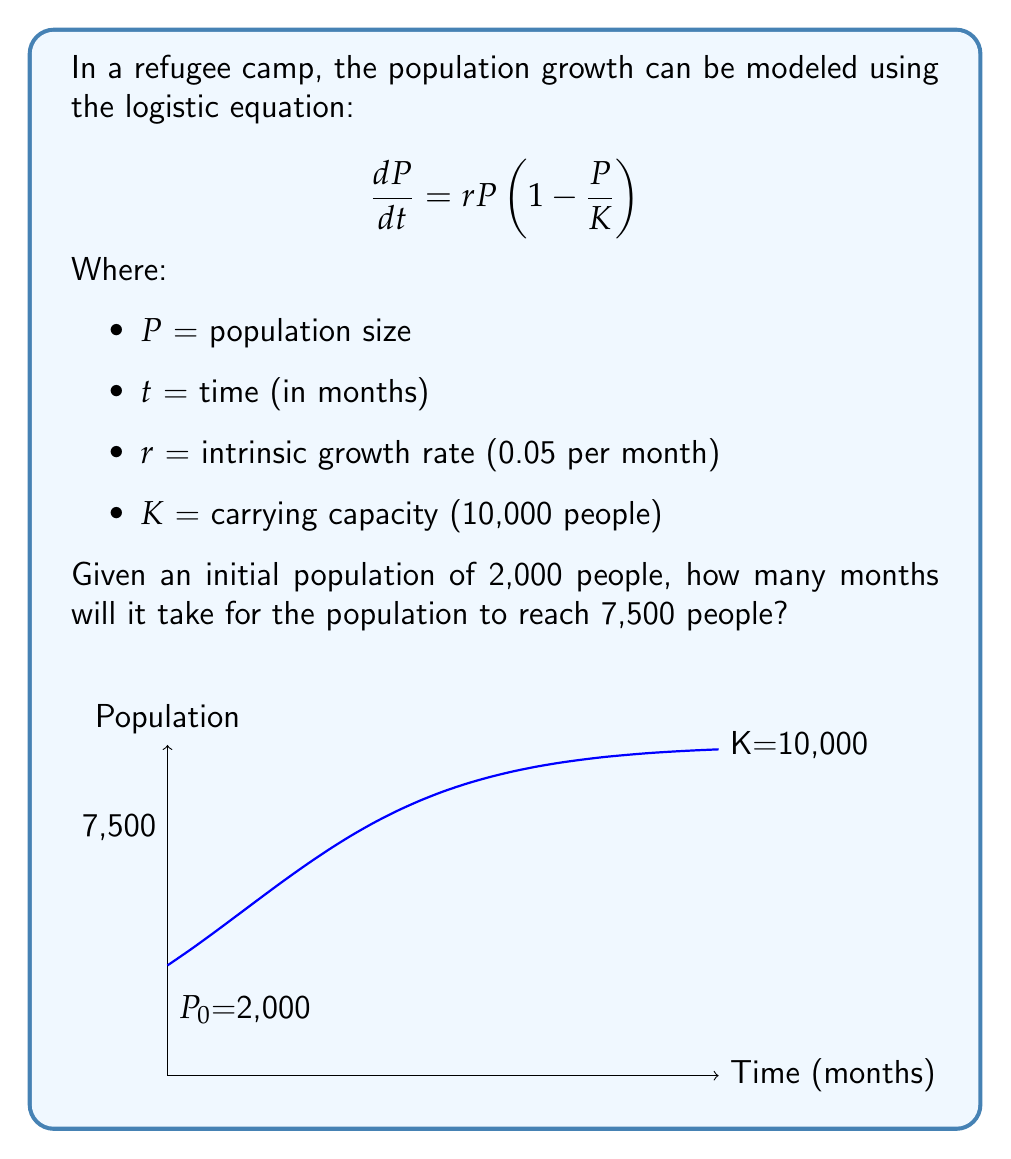Show me your answer to this math problem. To solve this problem, we need to use the solution to the logistic equation:

$$P(t) = \frac{K}{1 + (\frac{K}{P_0} - 1)e^{-rt}}$$

Where $P_0$ is the initial population.

Step 1: Substitute the known values into the equation:
$$7500 = \frac{10000}{1 + (\frac{10000}{2000} - 1)e^{-0.05t}}$$

Step 2: Simplify:
$$7500 = \frac{10000}{1 + 4e^{-0.05t}}$$

Step 3: Multiply both sides by the denominator:
$$7500(1 + 4e^{-0.05t}) = 10000$$

Step 4: Expand:
$$7500 + 30000e^{-0.05t} = 10000$$

Step 5: Subtract 7500 from both sides:
$$30000e^{-0.05t} = 2500$$

Step 6: Divide both sides by 30000:
$$e^{-0.05t} = \frac{1}{12}$$

Step 7: Take the natural log of both sides:
$$-0.05t = \ln(\frac{1}{12})$$

Step 8: Solve for t:
$$t = -\frac{\ln(\frac{1}{12})}{0.05} \approx 49.85$$

Therefore, it will take approximately 50 months for the population to reach 7,500 people.
Answer: 50 months 